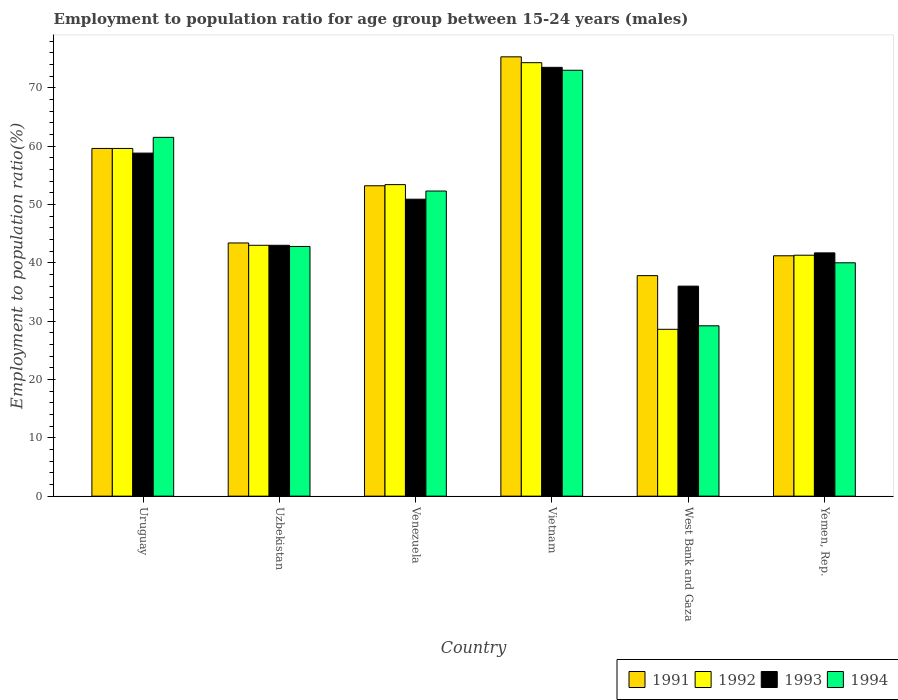How many groups of bars are there?
Offer a very short reply. 6. Are the number of bars per tick equal to the number of legend labels?
Ensure brevity in your answer.  Yes. Are the number of bars on each tick of the X-axis equal?
Give a very brief answer. Yes. How many bars are there on the 2nd tick from the left?
Make the answer very short. 4. What is the label of the 2nd group of bars from the left?
Keep it short and to the point. Uzbekistan. In how many cases, is the number of bars for a given country not equal to the number of legend labels?
Provide a succinct answer. 0. What is the employment to population ratio in 1994 in Yemen, Rep.?
Your answer should be very brief. 40. Across all countries, what is the maximum employment to population ratio in 1993?
Keep it short and to the point. 73.5. Across all countries, what is the minimum employment to population ratio in 1994?
Your answer should be compact. 29.2. In which country was the employment to population ratio in 1993 maximum?
Keep it short and to the point. Vietnam. In which country was the employment to population ratio in 1992 minimum?
Ensure brevity in your answer.  West Bank and Gaza. What is the total employment to population ratio in 1994 in the graph?
Offer a very short reply. 298.8. What is the difference between the employment to population ratio in 1994 in West Bank and Gaza and that in Yemen, Rep.?
Your answer should be compact. -10.8. What is the difference between the employment to population ratio in 1991 in Uruguay and the employment to population ratio in 1994 in Uzbekistan?
Offer a very short reply. 16.8. What is the average employment to population ratio in 1994 per country?
Provide a short and direct response. 49.8. What is the difference between the employment to population ratio of/in 1994 and employment to population ratio of/in 1991 in West Bank and Gaza?
Provide a succinct answer. -8.6. In how many countries, is the employment to population ratio in 1992 greater than 4 %?
Keep it short and to the point. 6. What is the ratio of the employment to population ratio in 1991 in Uzbekistan to that in Venezuela?
Your answer should be compact. 0.82. What is the difference between the highest and the second highest employment to population ratio in 1994?
Keep it short and to the point. 20.7. What is the difference between the highest and the lowest employment to population ratio in 1992?
Offer a very short reply. 45.7. Is it the case that in every country, the sum of the employment to population ratio in 1991 and employment to population ratio in 1994 is greater than the sum of employment to population ratio in 1993 and employment to population ratio in 1992?
Provide a succinct answer. No. What does the 2nd bar from the right in West Bank and Gaza represents?
Offer a very short reply. 1993. What is the difference between two consecutive major ticks on the Y-axis?
Offer a terse response. 10. Does the graph contain any zero values?
Offer a very short reply. No. Does the graph contain grids?
Make the answer very short. No. How are the legend labels stacked?
Give a very brief answer. Horizontal. What is the title of the graph?
Keep it short and to the point. Employment to population ratio for age group between 15-24 years (males). What is the label or title of the X-axis?
Your answer should be compact. Country. What is the Employment to population ratio(%) in 1991 in Uruguay?
Offer a very short reply. 59.6. What is the Employment to population ratio(%) in 1992 in Uruguay?
Keep it short and to the point. 59.6. What is the Employment to population ratio(%) of 1993 in Uruguay?
Your answer should be very brief. 58.8. What is the Employment to population ratio(%) of 1994 in Uruguay?
Ensure brevity in your answer.  61.5. What is the Employment to population ratio(%) in 1991 in Uzbekistan?
Provide a short and direct response. 43.4. What is the Employment to population ratio(%) of 1994 in Uzbekistan?
Your response must be concise. 42.8. What is the Employment to population ratio(%) in 1991 in Venezuela?
Ensure brevity in your answer.  53.2. What is the Employment to population ratio(%) in 1992 in Venezuela?
Offer a terse response. 53.4. What is the Employment to population ratio(%) of 1993 in Venezuela?
Keep it short and to the point. 50.9. What is the Employment to population ratio(%) in 1994 in Venezuela?
Offer a very short reply. 52.3. What is the Employment to population ratio(%) of 1991 in Vietnam?
Your answer should be very brief. 75.3. What is the Employment to population ratio(%) in 1992 in Vietnam?
Your response must be concise. 74.3. What is the Employment to population ratio(%) in 1993 in Vietnam?
Your answer should be compact. 73.5. What is the Employment to population ratio(%) of 1994 in Vietnam?
Your response must be concise. 73. What is the Employment to population ratio(%) in 1991 in West Bank and Gaza?
Make the answer very short. 37.8. What is the Employment to population ratio(%) of 1992 in West Bank and Gaza?
Your answer should be very brief. 28.6. What is the Employment to population ratio(%) of 1993 in West Bank and Gaza?
Provide a succinct answer. 36. What is the Employment to population ratio(%) of 1994 in West Bank and Gaza?
Keep it short and to the point. 29.2. What is the Employment to population ratio(%) in 1991 in Yemen, Rep.?
Keep it short and to the point. 41.2. What is the Employment to population ratio(%) of 1992 in Yemen, Rep.?
Provide a succinct answer. 41.3. What is the Employment to population ratio(%) of 1993 in Yemen, Rep.?
Ensure brevity in your answer.  41.7. What is the Employment to population ratio(%) in 1994 in Yemen, Rep.?
Your answer should be compact. 40. Across all countries, what is the maximum Employment to population ratio(%) in 1991?
Offer a very short reply. 75.3. Across all countries, what is the maximum Employment to population ratio(%) of 1992?
Your response must be concise. 74.3. Across all countries, what is the maximum Employment to population ratio(%) of 1993?
Offer a terse response. 73.5. Across all countries, what is the minimum Employment to population ratio(%) of 1991?
Your response must be concise. 37.8. Across all countries, what is the minimum Employment to population ratio(%) in 1992?
Provide a succinct answer. 28.6. Across all countries, what is the minimum Employment to population ratio(%) of 1993?
Ensure brevity in your answer.  36. Across all countries, what is the minimum Employment to population ratio(%) of 1994?
Your answer should be very brief. 29.2. What is the total Employment to population ratio(%) in 1991 in the graph?
Offer a terse response. 310.5. What is the total Employment to population ratio(%) of 1992 in the graph?
Offer a very short reply. 300.2. What is the total Employment to population ratio(%) of 1993 in the graph?
Offer a very short reply. 303.9. What is the total Employment to population ratio(%) of 1994 in the graph?
Keep it short and to the point. 298.8. What is the difference between the Employment to population ratio(%) of 1991 in Uruguay and that in Uzbekistan?
Your answer should be very brief. 16.2. What is the difference between the Employment to population ratio(%) of 1992 in Uruguay and that in Uzbekistan?
Offer a very short reply. 16.6. What is the difference between the Employment to population ratio(%) in 1994 in Uruguay and that in Uzbekistan?
Your response must be concise. 18.7. What is the difference between the Employment to population ratio(%) of 1991 in Uruguay and that in Venezuela?
Offer a terse response. 6.4. What is the difference between the Employment to population ratio(%) in 1992 in Uruguay and that in Venezuela?
Provide a succinct answer. 6.2. What is the difference between the Employment to population ratio(%) in 1994 in Uruguay and that in Venezuela?
Provide a succinct answer. 9.2. What is the difference between the Employment to population ratio(%) in 1991 in Uruguay and that in Vietnam?
Give a very brief answer. -15.7. What is the difference between the Employment to population ratio(%) in 1992 in Uruguay and that in Vietnam?
Your answer should be very brief. -14.7. What is the difference between the Employment to population ratio(%) in 1993 in Uruguay and that in Vietnam?
Ensure brevity in your answer.  -14.7. What is the difference between the Employment to population ratio(%) of 1991 in Uruguay and that in West Bank and Gaza?
Your response must be concise. 21.8. What is the difference between the Employment to population ratio(%) in 1992 in Uruguay and that in West Bank and Gaza?
Offer a very short reply. 31. What is the difference between the Employment to population ratio(%) of 1993 in Uruguay and that in West Bank and Gaza?
Your answer should be very brief. 22.8. What is the difference between the Employment to population ratio(%) in 1994 in Uruguay and that in West Bank and Gaza?
Give a very brief answer. 32.3. What is the difference between the Employment to population ratio(%) of 1994 in Uruguay and that in Yemen, Rep.?
Your answer should be very brief. 21.5. What is the difference between the Employment to population ratio(%) in 1991 in Uzbekistan and that in Venezuela?
Provide a short and direct response. -9.8. What is the difference between the Employment to population ratio(%) of 1992 in Uzbekistan and that in Venezuela?
Offer a terse response. -10.4. What is the difference between the Employment to population ratio(%) of 1991 in Uzbekistan and that in Vietnam?
Keep it short and to the point. -31.9. What is the difference between the Employment to population ratio(%) in 1992 in Uzbekistan and that in Vietnam?
Offer a terse response. -31.3. What is the difference between the Employment to population ratio(%) in 1993 in Uzbekistan and that in Vietnam?
Offer a terse response. -30.5. What is the difference between the Employment to population ratio(%) in 1994 in Uzbekistan and that in Vietnam?
Your answer should be compact. -30.2. What is the difference between the Employment to population ratio(%) in 1993 in Uzbekistan and that in West Bank and Gaza?
Ensure brevity in your answer.  7. What is the difference between the Employment to population ratio(%) of 1991 in Uzbekistan and that in Yemen, Rep.?
Your answer should be very brief. 2.2. What is the difference between the Employment to population ratio(%) of 1993 in Uzbekistan and that in Yemen, Rep.?
Offer a terse response. 1.3. What is the difference between the Employment to population ratio(%) of 1994 in Uzbekistan and that in Yemen, Rep.?
Offer a very short reply. 2.8. What is the difference between the Employment to population ratio(%) in 1991 in Venezuela and that in Vietnam?
Ensure brevity in your answer.  -22.1. What is the difference between the Employment to population ratio(%) in 1992 in Venezuela and that in Vietnam?
Provide a succinct answer. -20.9. What is the difference between the Employment to population ratio(%) in 1993 in Venezuela and that in Vietnam?
Make the answer very short. -22.6. What is the difference between the Employment to population ratio(%) of 1994 in Venezuela and that in Vietnam?
Keep it short and to the point. -20.7. What is the difference between the Employment to population ratio(%) in 1992 in Venezuela and that in West Bank and Gaza?
Make the answer very short. 24.8. What is the difference between the Employment to population ratio(%) in 1994 in Venezuela and that in West Bank and Gaza?
Your answer should be very brief. 23.1. What is the difference between the Employment to population ratio(%) of 1992 in Venezuela and that in Yemen, Rep.?
Your response must be concise. 12.1. What is the difference between the Employment to population ratio(%) of 1991 in Vietnam and that in West Bank and Gaza?
Provide a succinct answer. 37.5. What is the difference between the Employment to population ratio(%) of 1992 in Vietnam and that in West Bank and Gaza?
Offer a terse response. 45.7. What is the difference between the Employment to population ratio(%) in 1993 in Vietnam and that in West Bank and Gaza?
Keep it short and to the point. 37.5. What is the difference between the Employment to population ratio(%) in 1994 in Vietnam and that in West Bank and Gaza?
Provide a succinct answer. 43.8. What is the difference between the Employment to population ratio(%) of 1991 in Vietnam and that in Yemen, Rep.?
Your answer should be compact. 34.1. What is the difference between the Employment to population ratio(%) of 1992 in Vietnam and that in Yemen, Rep.?
Your response must be concise. 33. What is the difference between the Employment to population ratio(%) of 1993 in Vietnam and that in Yemen, Rep.?
Keep it short and to the point. 31.8. What is the difference between the Employment to population ratio(%) in 1991 in West Bank and Gaza and that in Yemen, Rep.?
Give a very brief answer. -3.4. What is the difference between the Employment to population ratio(%) in 1991 in Uruguay and the Employment to population ratio(%) in 1992 in Uzbekistan?
Provide a succinct answer. 16.6. What is the difference between the Employment to population ratio(%) of 1992 in Uruguay and the Employment to population ratio(%) of 1993 in Uzbekistan?
Keep it short and to the point. 16.6. What is the difference between the Employment to population ratio(%) of 1991 in Uruguay and the Employment to population ratio(%) of 1992 in Venezuela?
Make the answer very short. 6.2. What is the difference between the Employment to population ratio(%) of 1991 in Uruguay and the Employment to population ratio(%) of 1994 in Venezuela?
Your answer should be compact. 7.3. What is the difference between the Employment to population ratio(%) of 1993 in Uruguay and the Employment to population ratio(%) of 1994 in Venezuela?
Your answer should be very brief. 6.5. What is the difference between the Employment to population ratio(%) of 1991 in Uruguay and the Employment to population ratio(%) of 1992 in Vietnam?
Your response must be concise. -14.7. What is the difference between the Employment to population ratio(%) of 1991 in Uruguay and the Employment to population ratio(%) of 1993 in Vietnam?
Give a very brief answer. -13.9. What is the difference between the Employment to population ratio(%) of 1992 in Uruguay and the Employment to population ratio(%) of 1993 in Vietnam?
Keep it short and to the point. -13.9. What is the difference between the Employment to population ratio(%) in 1991 in Uruguay and the Employment to population ratio(%) in 1993 in West Bank and Gaza?
Your answer should be compact. 23.6. What is the difference between the Employment to population ratio(%) of 1991 in Uruguay and the Employment to population ratio(%) of 1994 in West Bank and Gaza?
Your response must be concise. 30.4. What is the difference between the Employment to population ratio(%) of 1992 in Uruguay and the Employment to population ratio(%) of 1993 in West Bank and Gaza?
Your answer should be very brief. 23.6. What is the difference between the Employment to population ratio(%) in 1992 in Uruguay and the Employment to population ratio(%) in 1994 in West Bank and Gaza?
Keep it short and to the point. 30.4. What is the difference between the Employment to population ratio(%) of 1993 in Uruguay and the Employment to population ratio(%) of 1994 in West Bank and Gaza?
Provide a short and direct response. 29.6. What is the difference between the Employment to population ratio(%) in 1991 in Uruguay and the Employment to population ratio(%) in 1993 in Yemen, Rep.?
Your answer should be compact. 17.9. What is the difference between the Employment to population ratio(%) in 1991 in Uruguay and the Employment to population ratio(%) in 1994 in Yemen, Rep.?
Provide a short and direct response. 19.6. What is the difference between the Employment to population ratio(%) in 1992 in Uruguay and the Employment to population ratio(%) in 1993 in Yemen, Rep.?
Your answer should be compact. 17.9. What is the difference between the Employment to population ratio(%) in 1992 in Uruguay and the Employment to population ratio(%) in 1994 in Yemen, Rep.?
Your answer should be very brief. 19.6. What is the difference between the Employment to population ratio(%) of 1993 in Uruguay and the Employment to population ratio(%) of 1994 in Yemen, Rep.?
Provide a succinct answer. 18.8. What is the difference between the Employment to population ratio(%) in 1991 in Uzbekistan and the Employment to population ratio(%) in 1992 in Venezuela?
Keep it short and to the point. -10. What is the difference between the Employment to population ratio(%) of 1992 in Uzbekistan and the Employment to population ratio(%) of 1994 in Venezuela?
Offer a very short reply. -9.3. What is the difference between the Employment to population ratio(%) in 1993 in Uzbekistan and the Employment to population ratio(%) in 1994 in Venezuela?
Offer a terse response. -9.3. What is the difference between the Employment to population ratio(%) of 1991 in Uzbekistan and the Employment to population ratio(%) of 1992 in Vietnam?
Provide a succinct answer. -30.9. What is the difference between the Employment to population ratio(%) of 1991 in Uzbekistan and the Employment to population ratio(%) of 1993 in Vietnam?
Give a very brief answer. -30.1. What is the difference between the Employment to population ratio(%) of 1991 in Uzbekistan and the Employment to population ratio(%) of 1994 in Vietnam?
Make the answer very short. -29.6. What is the difference between the Employment to population ratio(%) of 1992 in Uzbekistan and the Employment to population ratio(%) of 1993 in Vietnam?
Provide a succinct answer. -30.5. What is the difference between the Employment to population ratio(%) of 1991 in Uzbekistan and the Employment to population ratio(%) of 1994 in West Bank and Gaza?
Make the answer very short. 14.2. What is the difference between the Employment to population ratio(%) in 1992 in Uzbekistan and the Employment to population ratio(%) in 1993 in West Bank and Gaza?
Your response must be concise. 7. What is the difference between the Employment to population ratio(%) of 1991 in Uzbekistan and the Employment to population ratio(%) of 1992 in Yemen, Rep.?
Provide a short and direct response. 2.1. What is the difference between the Employment to population ratio(%) of 1993 in Uzbekistan and the Employment to population ratio(%) of 1994 in Yemen, Rep.?
Provide a succinct answer. 3. What is the difference between the Employment to population ratio(%) of 1991 in Venezuela and the Employment to population ratio(%) of 1992 in Vietnam?
Ensure brevity in your answer.  -21.1. What is the difference between the Employment to population ratio(%) in 1991 in Venezuela and the Employment to population ratio(%) in 1993 in Vietnam?
Offer a terse response. -20.3. What is the difference between the Employment to population ratio(%) in 1991 in Venezuela and the Employment to population ratio(%) in 1994 in Vietnam?
Ensure brevity in your answer.  -19.8. What is the difference between the Employment to population ratio(%) in 1992 in Venezuela and the Employment to population ratio(%) in 1993 in Vietnam?
Your response must be concise. -20.1. What is the difference between the Employment to population ratio(%) of 1992 in Venezuela and the Employment to population ratio(%) of 1994 in Vietnam?
Provide a succinct answer. -19.6. What is the difference between the Employment to population ratio(%) in 1993 in Venezuela and the Employment to population ratio(%) in 1994 in Vietnam?
Offer a very short reply. -22.1. What is the difference between the Employment to population ratio(%) in 1991 in Venezuela and the Employment to population ratio(%) in 1992 in West Bank and Gaza?
Offer a very short reply. 24.6. What is the difference between the Employment to population ratio(%) in 1991 in Venezuela and the Employment to population ratio(%) in 1994 in West Bank and Gaza?
Provide a short and direct response. 24. What is the difference between the Employment to population ratio(%) in 1992 in Venezuela and the Employment to population ratio(%) in 1993 in West Bank and Gaza?
Provide a succinct answer. 17.4. What is the difference between the Employment to population ratio(%) of 1992 in Venezuela and the Employment to population ratio(%) of 1994 in West Bank and Gaza?
Your answer should be compact. 24.2. What is the difference between the Employment to population ratio(%) of 1993 in Venezuela and the Employment to population ratio(%) of 1994 in West Bank and Gaza?
Provide a short and direct response. 21.7. What is the difference between the Employment to population ratio(%) in 1991 in Venezuela and the Employment to population ratio(%) in 1992 in Yemen, Rep.?
Give a very brief answer. 11.9. What is the difference between the Employment to population ratio(%) in 1991 in Venezuela and the Employment to population ratio(%) in 1993 in Yemen, Rep.?
Ensure brevity in your answer.  11.5. What is the difference between the Employment to population ratio(%) in 1993 in Venezuela and the Employment to population ratio(%) in 1994 in Yemen, Rep.?
Keep it short and to the point. 10.9. What is the difference between the Employment to population ratio(%) of 1991 in Vietnam and the Employment to population ratio(%) of 1992 in West Bank and Gaza?
Make the answer very short. 46.7. What is the difference between the Employment to population ratio(%) of 1991 in Vietnam and the Employment to population ratio(%) of 1993 in West Bank and Gaza?
Provide a succinct answer. 39.3. What is the difference between the Employment to population ratio(%) of 1991 in Vietnam and the Employment to population ratio(%) of 1994 in West Bank and Gaza?
Provide a short and direct response. 46.1. What is the difference between the Employment to population ratio(%) of 1992 in Vietnam and the Employment to population ratio(%) of 1993 in West Bank and Gaza?
Keep it short and to the point. 38.3. What is the difference between the Employment to population ratio(%) in 1992 in Vietnam and the Employment to population ratio(%) in 1994 in West Bank and Gaza?
Provide a succinct answer. 45.1. What is the difference between the Employment to population ratio(%) of 1993 in Vietnam and the Employment to population ratio(%) of 1994 in West Bank and Gaza?
Ensure brevity in your answer.  44.3. What is the difference between the Employment to population ratio(%) of 1991 in Vietnam and the Employment to population ratio(%) of 1993 in Yemen, Rep.?
Make the answer very short. 33.6. What is the difference between the Employment to population ratio(%) of 1991 in Vietnam and the Employment to population ratio(%) of 1994 in Yemen, Rep.?
Your answer should be very brief. 35.3. What is the difference between the Employment to population ratio(%) of 1992 in Vietnam and the Employment to population ratio(%) of 1993 in Yemen, Rep.?
Your response must be concise. 32.6. What is the difference between the Employment to population ratio(%) of 1992 in Vietnam and the Employment to population ratio(%) of 1994 in Yemen, Rep.?
Offer a very short reply. 34.3. What is the difference between the Employment to population ratio(%) of 1993 in Vietnam and the Employment to population ratio(%) of 1994 in Yemen, Rep.?
Give a very brief answer. 33.5. What is the difference between the Employment to population ratio(%) in 1991 in West Bank and Gaza and the Employment to population ratio(%) in 1993 in Yemen, Rep.?
Provide a succinct answer. -3.9. What is the difference between the Employment to population ratio(%) in 1991 in West Bank and Gaza and the Employment to population ratio(%) in 1994 in Yemen, Rep.?
Ensure brevity in your answer.  -2.2. What is the difference between the Employment to population ratio(%) of 1992 in West Bank and Gaza and the Employment to population ratio(%) of 1994 in Yemen, Rep.?
Provide a succinct answer. -11.4. What is the average Employment to population ratio(%) of 1991 per country?
Your response must be concise. 51.75. What is the average Employment to population ratio(%) in 1992 per country?
Provide a succinct answer. 50.03. What is the average Employment to population ratio(%) in 1993 per country?
Keep it short and to the point. 50.65. What is the average Employment to population ratio(%) of 1994 per country?
Ensure brevity in your answer.  49.8. What is the difference between the Employment to population ratio(%) of 1991 and Employment to population ratio(%) of 1992 in Uruguay?
Offer a terse response. 0. What is the difference between the Employment to population ratio(%) in 1993 and Employment to population ratio(%) in 1994 in Uruguay?
Your response must be concise. -2.7. What is the difference between the Employment to population ratio(%) of 1991 and Employment to population ratio(%) of 1994 in Uzbekistan?
Ensure brevity in your answer.  0.6. What is the difference between the Employment to population ratio(%) in 1992 and Employment to population ratio(%) in 1993 in Venezuela?
Offer a very short reply. 2.5. What is the difference between the Employment to population ratio(%) in 1992 and Employment to population ratio(%) in 1994 in Venezuela?
Keep it short and to the point. 1.1. What is the difference between the Employment to population ratio(%) of 1991 and Employment to population ratio(%) of 1992 in Vietnam?
Your answer should be compact. 1. What is the difference between the Employment to population ratio(%) of 1991 and Employment to population ratio(%) of 1994 in Vietnam?
Ensure brevity in your answer.  2.3. What is the difference between the Employment to population ratio(%) in 1992 and Employment to population ratio(%) in 1993 in Vietnam?
Your response must be concise. 0.8. What is the difference between the Employment to population ratio(%) of 1992 and Employment to population ratio(%) of 1994 in Vietnam?
Provide a succinct answer. 1.3. What is the difference between the Employment to population ratio(%) in 1991 and Employment to population ratio(%) in 1992 in West Bank and Gaza?
Provide a succinct answer. 9.2. What is the difference between the Employment to population ratio(%) of 1991 and Employment to population ratio(%) of 1993 in West Bank and Gaza?
Make the answer very short. 1.8. What is the difference between the Employment to population ratio(%) of 1991 and Employment to population ratio(%) of 1994 in West Bank and Gaza?
Your answer should be very brief. 8.6. What is the difference between the Employment to population ratio(%) of 1992 and Employment to population ratio(%) of 1993 in West Bank and Gaza?
Your answer should be very brief. -7.4. What is the difference between the Employment to population ratio(%) of 1993 and Employment to population ratio(%) of 1994 in West Bank and Gaza?
Your answer should be compact. 6.8. What is the difference between the Employment to population ratio(%) in 1991 and Employment to population ratio(%) in 1992 in Yemen, Rep.?
Your answer should be compact. -0.1. What is the difference between the Employment to population ratio(%) in 1991 and Employment to population ratio(%) in 1993 in Yemen, Rep.?
Offer a very short reply. -0.5. What is the difference between the Employment to population ratio(%) of 1991 and Employment to population ratio(%) of 1994 in Yemen, Rep.?
Offer a very short reply. 1.2. What is the difference between the Employment to population ratio(%) in 1992 and Employment to population ratio(%) in 1994 in Yemen, Rep.?
Provide a succinct answer. 1.3. What is the difference between the Employment to population ratio(%) of 1993 and Employment to population ratio(%) of 1994 in Yemen, Rep.?
Give a very brief answer. 1.7. What is the ratio of the Employment to population ratio(%) of 1991 in Uruguay to that in Uzbekistan?
Your answer should be very brief. 1.37. What is the ratio of the Employment to population ratio(%) of 1992 in Uruguay to that in Uzbekistan?
Provide a short and direct response. 1.39. What is the ratio of the Employment to population ratio(%) in 1993 in Uruguay to that in Uzbekistan?
Keep it short and to the point. 1.37. What is the ratio of the Employment to population ratio(%) in 1994 in Uruguay to that in Uzbekistan?
Give a very brief answer. 1.44. What is the ratio of the Employment to population ratio(%) of 1991 in Uruguay to that in Venezuela?
Provide a short and direct response. 1.12. What is the ratio of the Employment to population ratio(%) of 1992 in Uruguay to that in Venezuela?
Your answer should be very brief. 1.12. What is the ratio of the Employment to population ratio(%) in 1993 in Uruguay to that in Venezuela?
Ensure brevity in your answer.  1.16. What is the ratio of the Employment to population ratio(%) in 1994 in Uruguay to that in Venezuela?
Your response must be concise. 1.18. What is the ratio of the Employment to population ratio(%) in 1991 in Uruguay to that in Vietnam?
Offer a very short reply. 0.79. What is the ratio of the Employment to population ratio(%) of 1992 in Uruguay to that in Vietnam?
Keep it short and to the point. 0.8. What is the ratio of the Employment to population ratio(%) in 1993 in Uruguay to that in Vietnam?
Ensure brevity in your answer.  0.8. What is the ratio of the Employment to population ratio(%) of 1994 in Uruguay to that in Vietnam?
Your answer should be very brief. 0.84. What is the ratio of the Employment to population ratio(%) of 1991 in Uruguay to that in West Bank and Gaza?
Your answer should be very brief. 1.58. What is the ratio of the Employment to population ratio(%) in 1992 in Uruguay to that in West Bank and Gaza?
Your response must be concise. 2.08. What is the ratio of the Employment to population ratio(%) of 1993 in Uruguay to that in West Bank and Gaza?
Your response must be concise. 1.63. What is the ratio of the Employment to population ratio(%) in 1994 in Uruguay to that in West Bank and Gaza?
Your response must be concise. 2.11. What is the ratio of the Employment to population ratio(%) in 1991 in Uruguay to that in Yemen, Rep.?
Your answer should be compact. 1.45. What is the ratio of the Employment to population ratio(%) of 1992 in Uruguay to that in Yemen, Rep.?
Ensure brevity in your answer.  1.44. What is the ratio of the Employment to population ratio(%) of 1993 in Uruguay to that in Yemen, Rep.?
Make the answer very short. 1.41. What is the ratio of the Employment to population ratio(%) of 1994 in Uruguay to that in Yemen, Rep.?
Offer a very short reply. 1.54. What is the ratio of the Employment to population ratio(%) of 1991 in Uzbekistan to that in Venezuela?
Offer a terse response. 0.82. What is the ratio of the Employment to population ratio(%) in 1992 in Uzbekistan to that in Venezuela?
Your answer should be compact. 0.81. What is the ratio of the Employment to population ratio(%) in 1993 in Uzbekistan to that in Venezuela?
Your answer should be compact. 0.84. What is the ratio of the Employment to population ratio(%) in 1994 in Uzbekistan to that in Venezuela?
Offer a terse response. 0.82. What is the ratio of the Employment to population ratio(%) in 1991 in Uzbekistan to that in Vietnam?
Offer a terse response. 0.58. What is the ratio of the Employment to population ratio(%) in 1992 in Uzbekistan to that in Vietnam?
Make the answer very short. 0.58. What is the ratio of the Employment to population ratio(%) in 1993 in Uzbekistan to that in Vietnam?
Offer a terse response. 0.58. What is the ratio of the Employment to population ratio(%) of 1994 in Uzbekistan to that in Vietnam?
Give a very brief answer. 0.59. What is the ratio of the Employment to population ratio(%) of 1991 in Uzbekistan to that in West Bank and Gaza?
Your response must be concise. 1.15. What is the ratio of the Employment to population ratio(%) in 1992 in Uzbekistan to that in West Bank and Gaza?
Offer a terse response. 1.5. What is the ratio of the Employment to population ratio(%) of 1993 in Uzbekistan to that in West Bank and Gaza?
Your answer should be very brief. 1.19. What is the ratio of the Employment to population ratio(%) in 1994 in Uzbekistan to that in West Bank and Gaza?
Offer a terse response. 1.47. What is the ratio of the Employment to population ratio(%) of 1991 in Uzbekistan to that in Yemen, Rep.?
Make the answer very short. 1.05. What is the ratio of the Employment to population ratio(%) of 1992 in Uzbekistan to that in Yemen, Rep.?
Your answer should be compact. 1.04. What is the ratio of the Employment to population ratio(%) of 1993 in Uzbekistan to that in Yemen, Rep.?
Your answer should be compact. 1.03. What is the ratio of the Employment to population ratio(%) in 1994 in Uzbekistan to that in Yemen, Rep.?
Your answer should be very brief. 1.07. What is the ratio of the Employment to population ratio(%) in 1991 in Venezuela to that in Vietnam?
Offer a terse response. 0.71. What is the ratio of the Employment to population ratio(%) of 1992 in Venezuela to that in Vietnam?
Provide a succinct answer. 0.72. What is the ratio of the Employment to population ratio(%) of 1993 in Venezuela to that in Vietnam?
Provide a short and direct response. 0.69. What is the ratio of the Employment to population ratio(%) in 1994 in Venezuela to that in Vietnam?
Keep it short and to the point. 0.72. What is the ratio of the Employment to population ratio(%) in 1991 in Venezuela to that in West Bank and Gaza?
Ensure brevity in your answer.  1.41. What is the ratio of the Employment to population ratio(%) of 1992 in Venezuela to that in West Bank and Gaza?
Make the answer very short. 1.87. What is the ratio of the Employment to population ratio(%) in 1993 in Venezuela to that in West Bank and Gaza?
Offer a terse response. 1.41. What is the ratio of the Employment to population ratio(%) of 1994 in Venezuela to that in West Bank and Gaza?
Ensure brevity in your answer.  1.79. What is the ratio of the Employment to population ratio(%) of 1991 in Venezuela to that in Yemen, Rep.?
Ensure brevity in your answer.  1.29. What is the ratio of the Employment to population ratio(%) in 1992 in Venezuela to that in Yemen, Rep.?
Your response must be concise. 1.29. What is the ratio of the Employment to population ratio(%) in 1993 in Venezuela to that in Yemen, Rep.?
Give a very brief answer. 1.22. What is the ratio of the Employment to population ratio(%) in 1994 in Venezuela to that in Yemen, Rep.?
Provide a succinct answer. 1.31. What is the ratio of the Employment to population ratio(%) in 1991 in Vietnam to that in West Bank and Gaza?
Your answer should be very brief. 1.99. What is the ratio of the Employment to population ratio(%) of 1992 in Vietnam to that in West Bank and Gaza?
Make the answer very short. 2.6. What is the ratio of the Employment to population ratio(%) of 1993 in Vietnam to that in West Bank and Gaza?
Offer a terse response. 2.04. What is the ratio of the Employment to population ratio(%) of 1991 in Vietnam to that in Yemen, Rep.?
Provide a short and direct response. 1.83. What is the ratio of the Employment to population ratio(%) of 1992 in Vietnam to that in Yemen, Rep.?
Offer a terse response. 1.8. What is the ratio of the Employment to population ratio(%) of 1993 in Vietnam to that in Yemen, Rep.?
Offer a terse response. 1.76. What is the ratio of the Employment to population ratio(%) in 1994 in Vietnam to that in Yemen, Rep.?
Provide a succinct answer. 1.82. What is the ratio of the Employment to population ratio(%) in 1991 in West Bank and Gaza to that in Yemen, Rep.?
Ensure brevity in your answer.  0.92. What is the ratio of the Employment to population ratio(%) of 1992 in West Bank and Gaza to that in Yemen, Rep.?
Ensure brevity in your answer.  0.69. What is the ratio of the Employment to population ratio(%) in 1993 in West Bank and Gaza to that in Yemen, Rep.?
Keep it short and to the point. 0.86. What is the ratio of the Employment to population ratio(%) of 1994 in West Bank and Gaza to that in Yemen, Rep.?
Ensure brevity in your answer.  0.73. What is the difference between the highest and the second highest Employment to population ratio(%) in 1992?
Keep it short and to the point. 14.7. What is the difference between the highest and the lowest Employment to population ratio(%) in 1991?
Your answer should be compact. 37.5. What is the difference between the highest and the lowest Employment to population ratio(%) in 1992?
Your answer should be compact. 45.7. What is the difference between the highest and the lowest Employment to population ratio(%) of 1993?
Offer a terse response. 37.5. What is the difference between the highest and the lowest Employment to population ratio(%) in 1994?
Your answer should be compact. 43.8. 